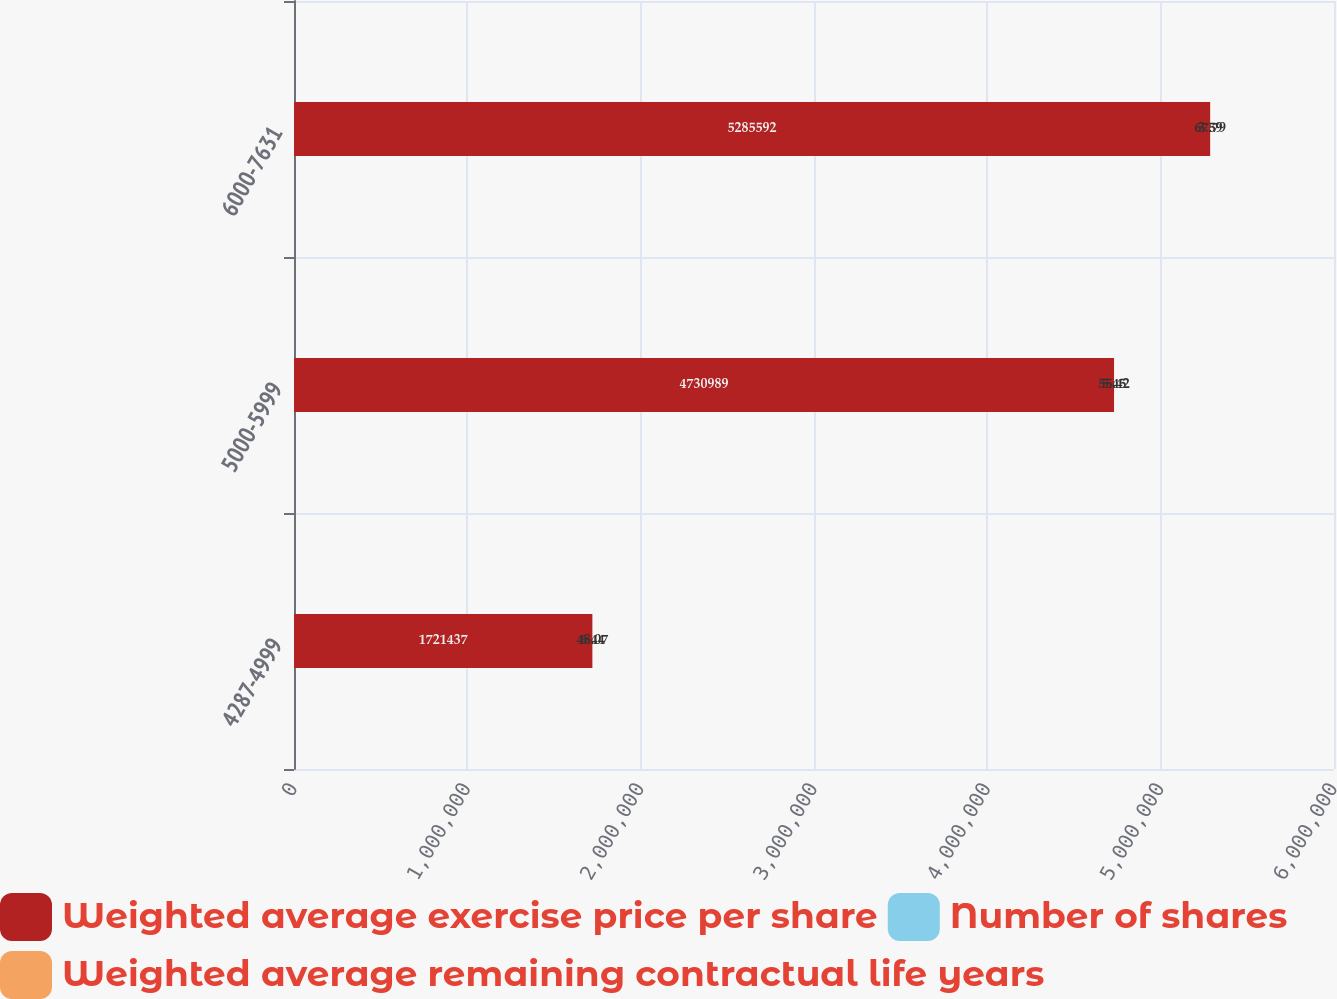<chart> <loc_0><loc_0><loc_500><loc_500><stacked_bar_chart><ecel><fcel>4287-4999<fcel>5000-5999<fcel>6000-7631<nl><fcel>Weighted average exercise price per share<fcel>1.72144e+06<fcel>4.73099e+06<fcel>5.28559e+06<nl><fcel>Number of shares<fcel>6.44<fcel>5.45<fcel>3.59<nl><fcel>Weighted average remaining contractual life years<fcel>48.07<fcel>55.42<fcel>67.79<nl></chart> 